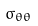<formula> <loc_0><loc_0><loc_500><loc_500>\sigma _ { \theta \theta }</formula> 